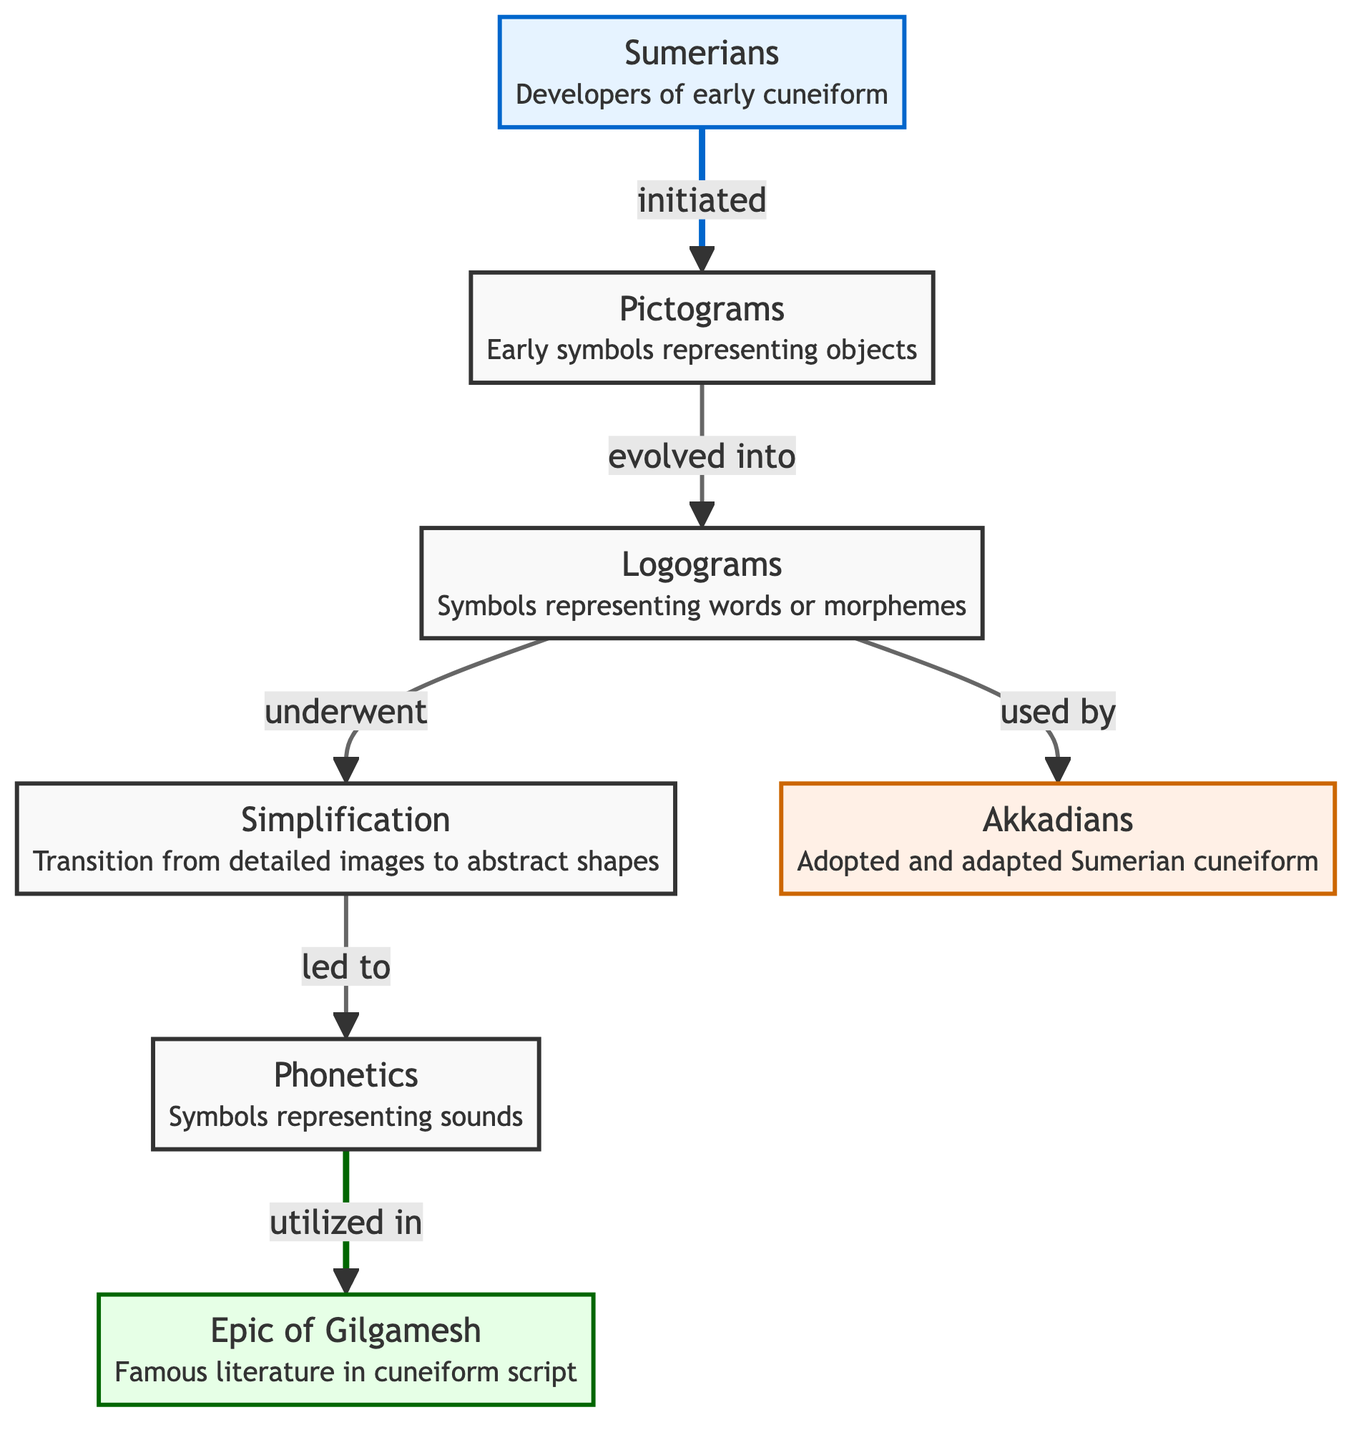What is the starting point in the evolution of cuneiform writing? The diagram indicates that the Sumerians, represented by the node labeled "Sumerians," initiated the process by developing early cuneiform, which then evolved from pictograms.
Answer: Sumerians What type of symbols do pictograms represent? The diagram clearly states that pictograms are early symbols that represent objects. This is shown directly in the text associated with the pictograms node.
Answer: Objects How many nodes are directly connected to logograms? By examining the diagram, we see that the node labeled "Logograms" has two direct connections: one to "Pictograms" (showing the evolutionary relationship) and another to "Simplification.” Therefore, it has two connected nodes.
Answer: 2 Which entity adopted and adapted Sumerian cuneiform? The diagram indicates that the Akkadians adopted and adapted Sumerian cuneiform, as denoted in the connection from "Logograms" to "Akkadians.”
Answer: Akkadians What was the result of the simplification process in cuneiform evolution? According to the diagram, the simplification led to phonetics, demonstrating that as symbols became more abstract, they transitioned to representing sounds.
Answer: Phonetics What literary work is mentioned in relation to the use of phonetics? The diagram specifies that the "Epic of Gilgamesh" was utilized in the context of phonetics, meaning this literary piece utilized the phonetic symbols developed from the cuneiform writing system.
Answer: Epic of Gilgamesh Describe the transition from logograms to another system in cuneiform writing. The diagram illustrates that logograms underwent a process called simplification. It is a transition where detailed images evolved to more abstract shapes, which eventually led to the use of phonetics.
Answer: Simplification How did the development of cuneiform start according to the diagram? The diagram shows that the development of cuneiform writing started with the Sumerians, who initiated the creation of pictograms, the first type of symbol used in this writing system.
Answer: Pictograms What does the node "Simplification" signify in the context of cuneiform writing evolution? The node labeled "Simplification" represents a significant change in cuneiform writing where detailed images transitioned to more abstract shapes, demonstrating an evolution process that made the script more versatile.
Answer: Transition from detailed images to abstract shapes 